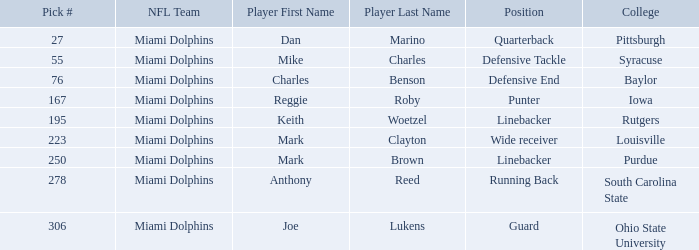Which Player has a Pick # lower than 223 and a Defensive End Position? Charles Benson. 